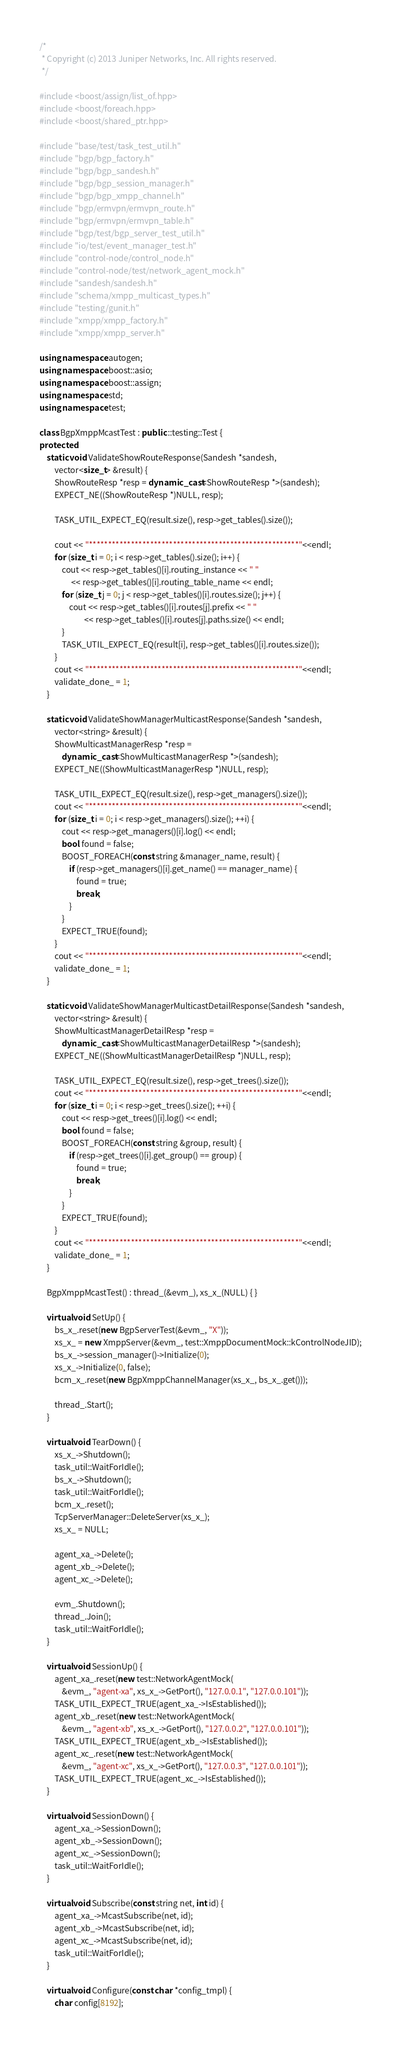<code> <loc_0><loc_0><loc_500><loc_500><_C++_>/*
 * Copyright (c) 2013 Juniper Networks, Inc. All rights reserved.
 */

#include <boost/assign/list_of.hpp>
#include <boost/foreach.hpp>
#include <boost/shared_ptr.hpp>

#include "base/test/task_test_util.h"
#include "bgp/bgp_factory.h"
#include "bgp/bgp_sandesh.h"
#include "bgp/bgp_session_manager.h"
#include "bgp/bgp_xmpp_channel.h"
#include "bgp/ermvpn/ermvpn_route.h"
#include "bgp/ermvpn/ermvpn_table.h"
#include "bgp/test/bgp_server_test_util.h"
#include "io/test/event_manager_test.h"
#include "control-node/control_node.h"
#include "control-node/test/network_agent_mock.h"
#include "sandesh/sandesh.h"
#include "schema/xmpp_multicast_types.h"
#include "testing/gunit.h"
#include "xmpp/xmpp_factory.h"
#include "xmpp/xmpp_server.h"

using namespace autogen;
using namespace boost::asio;
using namespace boost::assign;
using namespace std;
using namespace test;

class BgpXmppMcastTest : public ::testing::Test {
protected:
    static void ValidateShowRouteResponse(Sandesh *sandesh,
        vector<size_t> &result) {
        ShowRouteResp *resp = dynamic_cast<ShowRouteResp *>(sandesh);
        EXPECT_NE((ShowRouteResp *)NULL, resp);

        TASK_UTIL_EXPECT_EQ(result.size(), resp->get_tables().size());

        cout << "*******************************************************"<<endl;
        for (size_t i = 0; i < resp->get_tables().size(); i++) {
            cout << resp->get_tables()[i].routing_instance << " "
                 << resp->get_tables()[i].routing_table_name << endl;
            for (size_t j = 0; j < resp->get_tables()[i].routes.size(); j++) {
                cout << resp->get_tables()[i].routes[j].prefix << " "
                        << resp->get_tables()[i].routes[j].paths.size() << endl;
            }
            TASK_UTIL_EXPECT_EQ(result[i], resp->get_tables()[i].routes.size());
        }
        cout << "*******************************************************"<<endl;
        validate_done_ = 1;
    }

    static void ValidateShowManagerMulticastResponse(Sandesh *sandesh,
        vector<string> &result) {
        ShowMulticastManagerResp *resp =
            dynamic_cast<ShowMulticastManagerResp *>(sandesh);
        EXPECT_NE((ShowMulticastManagerResp *)NULL, resp);

        TASK_UTIL_EXPECT_EQ(result.size(), resp->get_managers().size());
        cout << "*******************************************************"<<endl;
        for (size_t i = 0; i < resp->get_managers().size(); ++i) {
            cout << resp->get_managers()[i].log() << endl;
            bool found = false;
            BOOST_FOREACH(const string &manager_name, result) {
                if (resp->get_managers()[i].get_name() == manager_name) {
                    found = true;
                    break;
                }
            }
            EXPECT_TRUE(found);
        }
        cout << "*******************************************************"<<endl;
        validate_done_ = 1;
    }

    static void ValidateShowManagerMulticastDetailResponse(Sandesh *sandesh,
        vector<string> &result) {
        ShowMulticastManagerDetailResp *resp =
            dynamic_cast<ShowMulticastManagerDetailResp *>(sandesh);
        EXPECT_NE((ShowMulticastManagerDetailResp *)NULL, resp);

        TASK_UTIL_EXPECT_EQ(result.size(), resp->get_trees().size());
        cout << "*******************************************************"<<endl;
        for (size_t i = 0; i < resp->get_trees().size(); ++i) {
            cout << resp->get_trees()[i].log() << endl;
            bool found = false;
            BOOST_FOREACH(const string &group, result) {
                if (resp->get_trees()[i].get_group() == group) {
                    found = true;
                    break;
                }
            }
            EXPECT_TRUE(found);
        }
        cout << "*******************************************************"<<endl;
        validate_done_ = 1;
    }

    BgpXmppMcastTest() : thread_(&evm_), xs_x_(NULL) { }

    virtual void SetUp() {
        bs_x_.reset(new BgpServerTest(&evm_, "X"));
        xs_x_ = new XmppServer(&evm_, test::XmppDocumentMock::kControlNodeJID);
        bs_x_->session_manager()->Initialize(0);
        xs_x_->Initialize(0, false);
        bcm_x_.reset(new BgpXmppChannelManager(xs_x_, bs_x_.get()));

        thread_.Start();
    }

    virtual void TearDown() {
        xs_x_->Shutdown();
        task_util::WaitForIdle();
        bs_x_->Shutdown();
        task_util::WaitForIdle();
        bcm_x_.reset();
        TcpServerManager::DeleteServer(xs_x_);
        xs_x_ = NULL;

        agent_xa_->Delete();
        agent_xb_->Delete();
        agent_xc_->Delete();

        evm_.Shutdown();
        thread_.Join();
        task_util::WaitForIdle();
    }

    virtual void SessionUp() {
        agent_xa_.reset(new test::NetworkAgentMock(
            &evm_, "agent-xa", xs_x_->GetPort(), "127.0.0.1", "127.0.0.101"));
        TASK_UTIL_EXPECT_TRUE(agent_xa_->IsEstablished());
        agent_xb_.reset(new test::NetworkAgentMock(
            &evm_, "agent-xb", xs_x_->GetPort(), "127.0.0.2", "127.0.0.101"));
        TASK_UTIL_EXPECT_TRUE(agent_xb_->IsEstablished());
        agent_xc_.reset(new test::NetworkAgentMock(
            &evm_, "agent-xc", xs_x_->GetPort(), "127.0.0.3", "127.0.0.101"));
        TASK_UTIL_EXPECT_TRUE(agent_xc_->IsEstablished());
    }

    virtual void SessionDown() {
        agent_xa_->SessionDown();
        agent_xb_->SessionDown();
        agent_xc_->SessionDown();
        task_util::WaitForIdle();
    }

    virtual void Subscribe(const string net, int id) {
        agent_xa_->McastSubscribe(net, id);
        agent_xb_->McastSubscribe(net, id);
        agent_xc_->McastSubscribe(net, id);
        task_util::WaitForIdle();
    }

    virtual void Configure(const char *config_tmpl) {
        char config[8192];</code> 